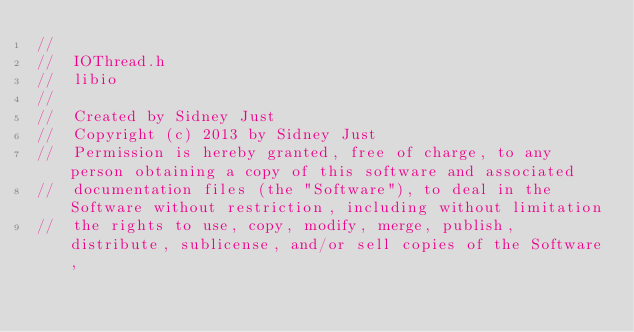<code> <loc_0><loc_0><loc_500><loc_500><_C_>//
//  IOThread.h
//  libio
//
//  Created by Sidney Just
//  Copyright (c) 2013 by Sidney Just
//  Permission is hereby granted, free of charge, to any person obtaining a copy of this software and associated 
//  documentation files (the "Software"), to deal in the Software without restriction, including without limitation 
//  the rights to use, copy, modify, merge, publish, distribute, sublicense, and/or sell copies of the Software, </code> 